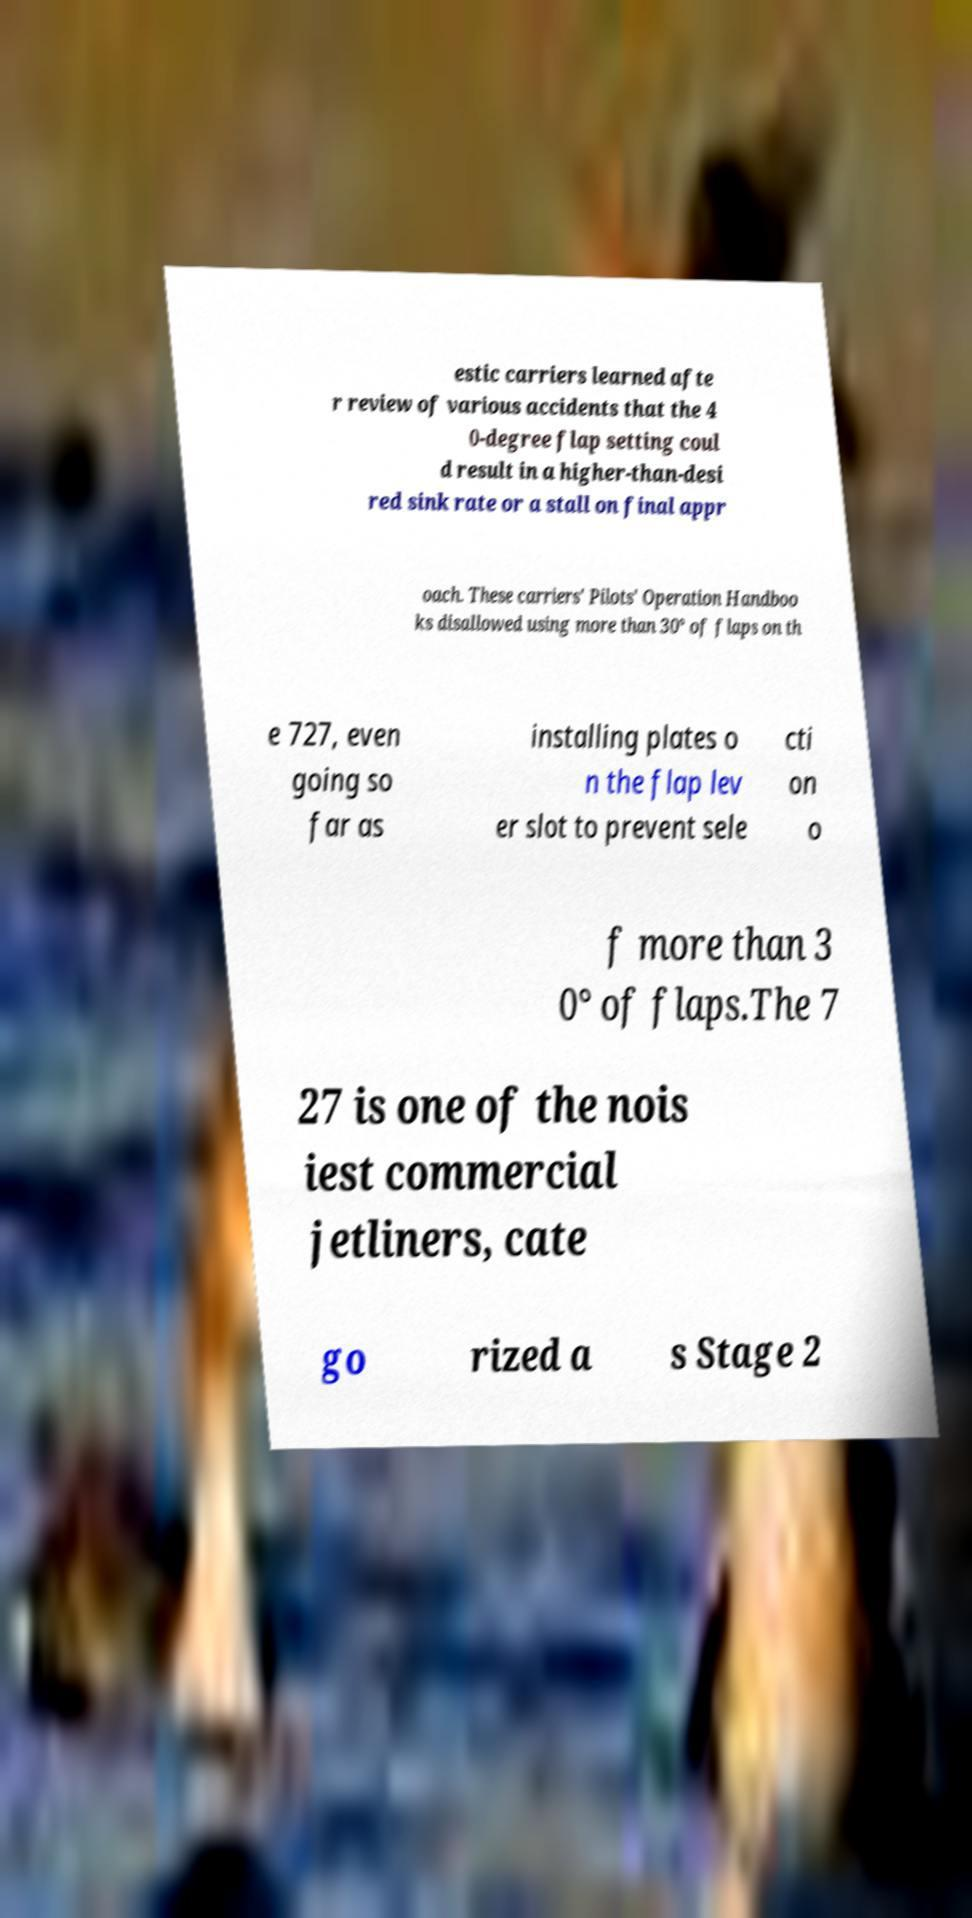There's text embedded in this image that I need extracted. Can you transcribe it verbatim? estic carriers learned afte r review of various accidents that the 4 0-degree flap setting coul d result in a higher-than-desi red sink rate or a stall on final appr oach. These carriers' Pilots' Operation Handboo ks disallowed using more than 30° of flaps on th e 727, even going so far as installing plates o n the flap lev er slot to prevent sele cti on o f more than 3 0° of flaps.The 7 27 is one of the nois iest commercial jetliners, cate go rized a s Stage 2 